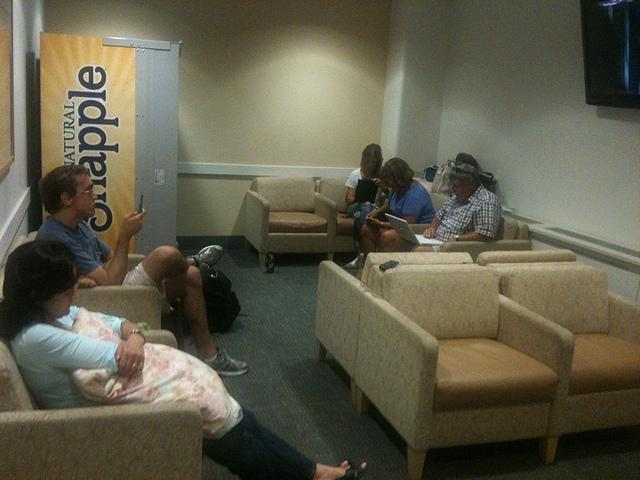What sort of beverages are most readily available here? snapple 